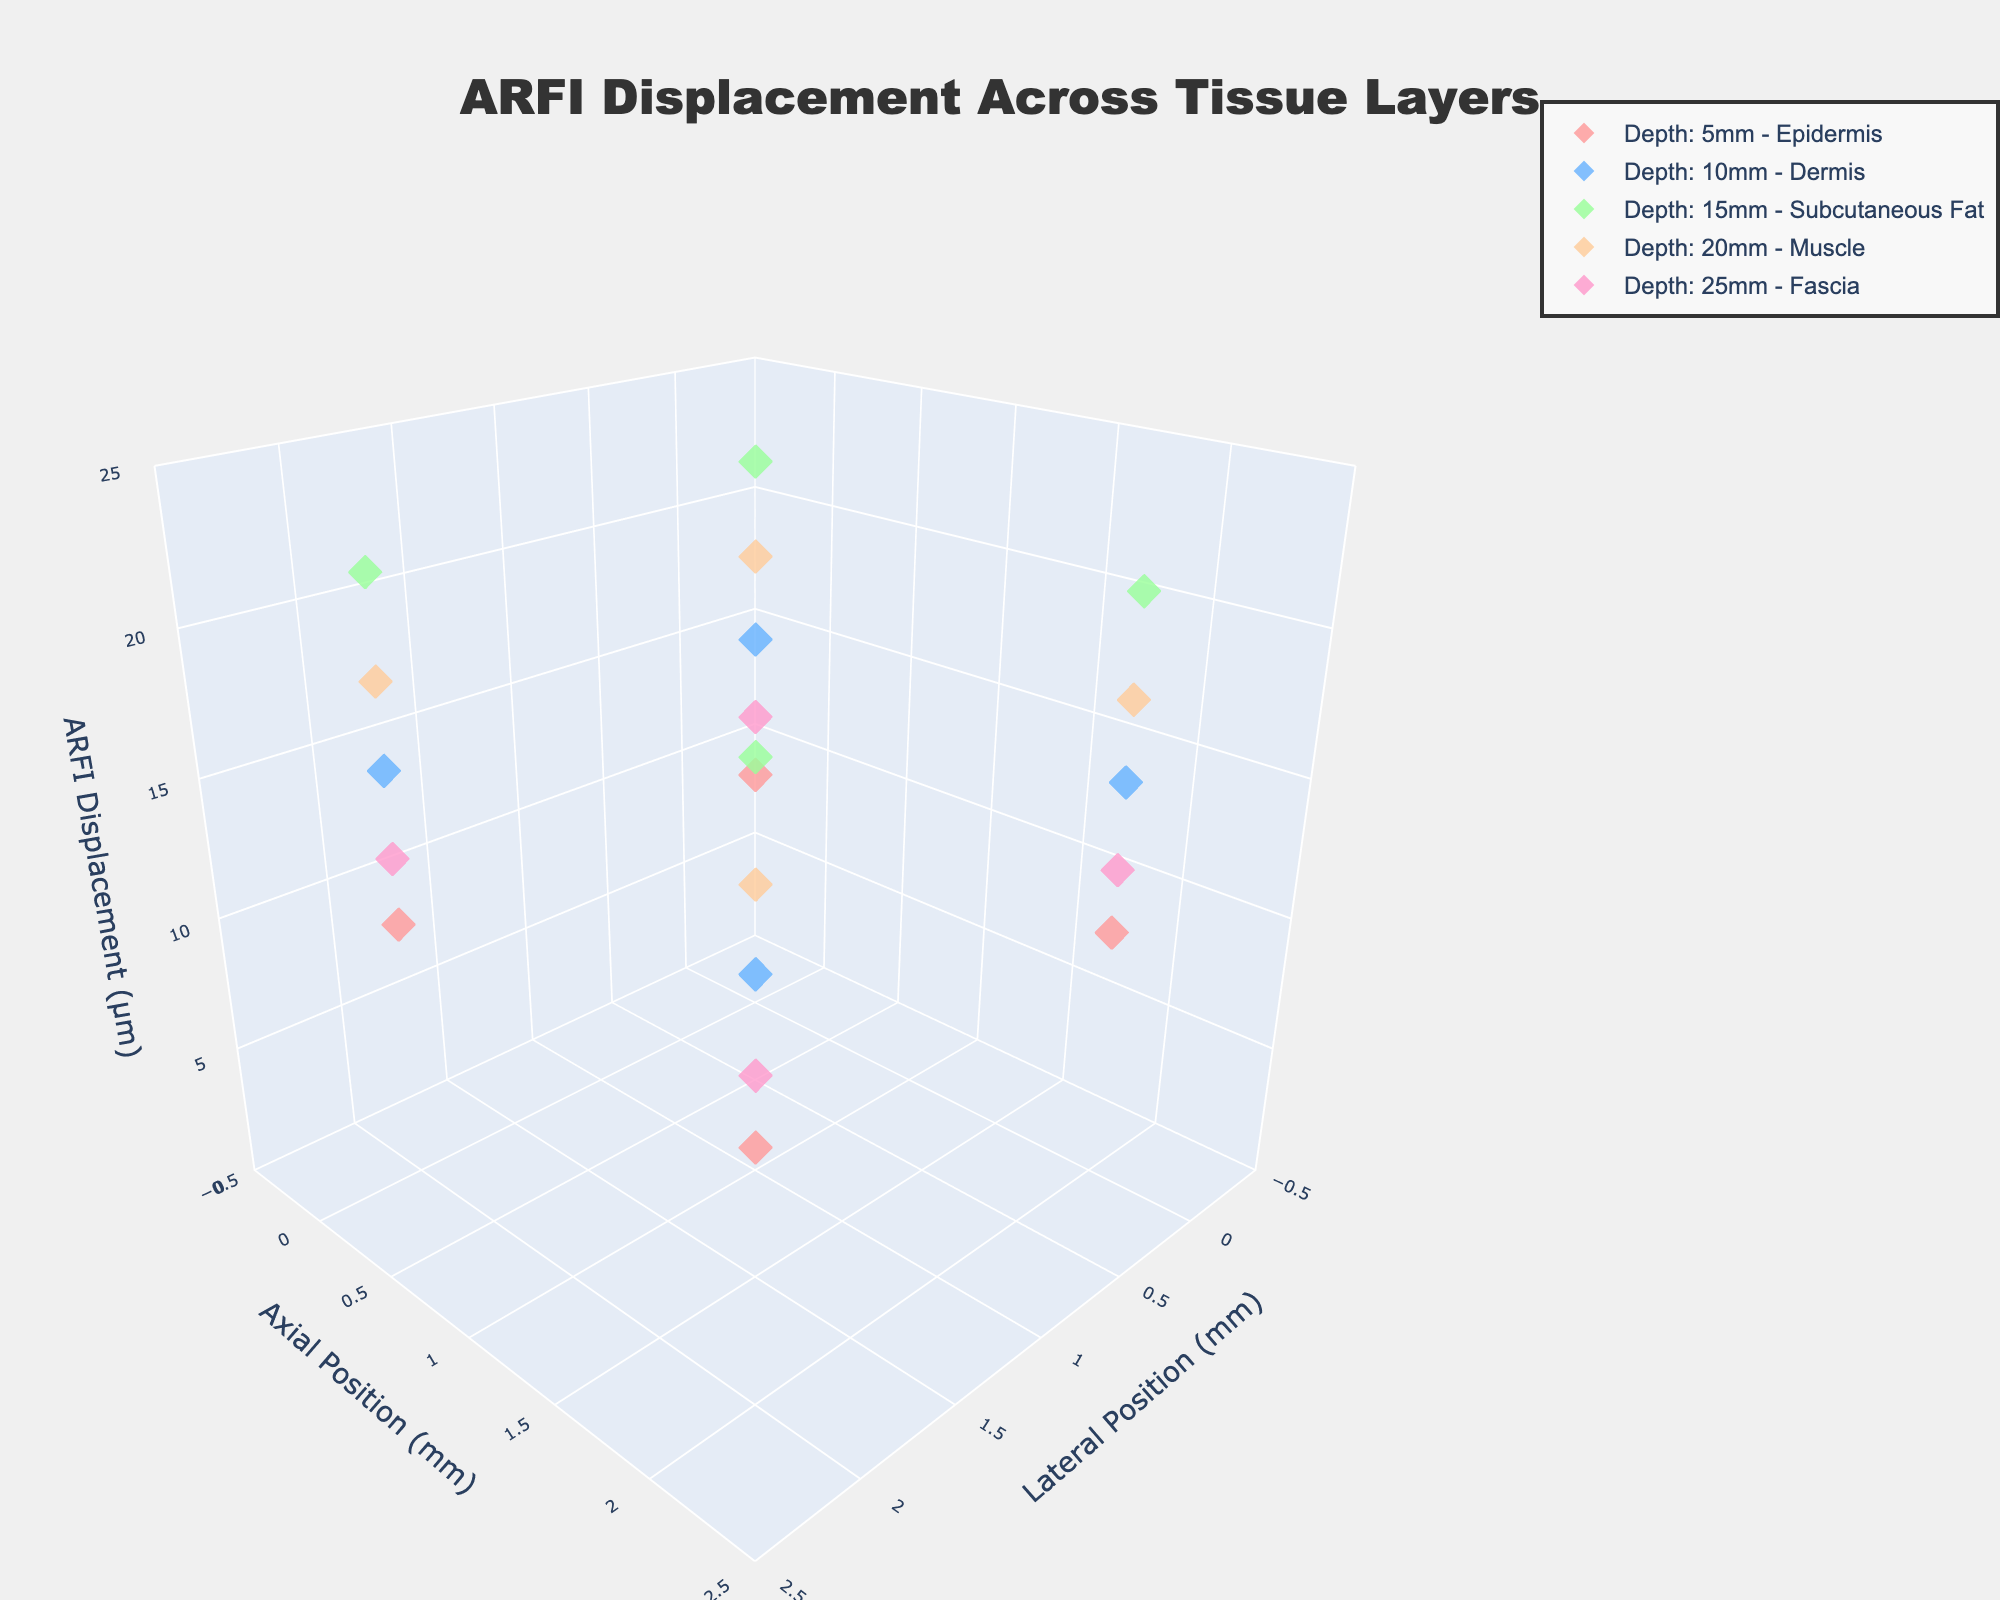Which axis represents the ARFI displacement? The z-axis title indicates "ARFI Displacement (µm)", thus the ARFI displacement is represented by the z-axis.
Answer: z-axis What color represents data points at 10 mm depth? The fifth series uses a color related to blue, as indicated in the legend where each tissue depth has a specific color.
Answer: blue How many tissue layers are represented in the figure? The legend shows each tissue depth's trace and layer name, indicating a total of 5 different layers.
Answer: 5 What is the highest ARFI displacement value and in which tissue layer is it found? The figure shows a 3D scatter plot where the maximum ARFI displacement is around 22.4 µm, which can be identified in the legend with the Subcutaneous Fat tissue layer at 15mm depth.
Answer: 22.4 µm in Subcutaneous Fat Which tissue layer displays the lowest ARFI displacement values? The z-axis range and the positions of the data points illustrate that the lowest ARFI displacements are around 10 µm, seen in the Epidermis layer.
Answer: Epidermis What is the range of the lateral positions analyzed in the plot? The x-axis title "Lateral Position (mm)" and the axis range from about -0.5 to 2.5 provide this information.
Answer: -0.5 to 2.5 mm How does the ARFI displacement differ between 5 mm and 20 mm depth? By comparing both depths on the z-axis, the displacement at 5 mm is around 10 µm, while at 20 mm, it is around 18-19 µm.
Answer: Around 8-9 µm higher at 20 mm depth than at 5 mm depth What general trend can be seen in the ARFI displacement as depth increases? Analyzing each scatter's z-axis values reveals an increasing trend in ARFI displacement from 10 µm at the shallowest to around 22.4 µm at around 15mm depth, then decreasing at depths beyond that.
Answer: Increases then decreases 